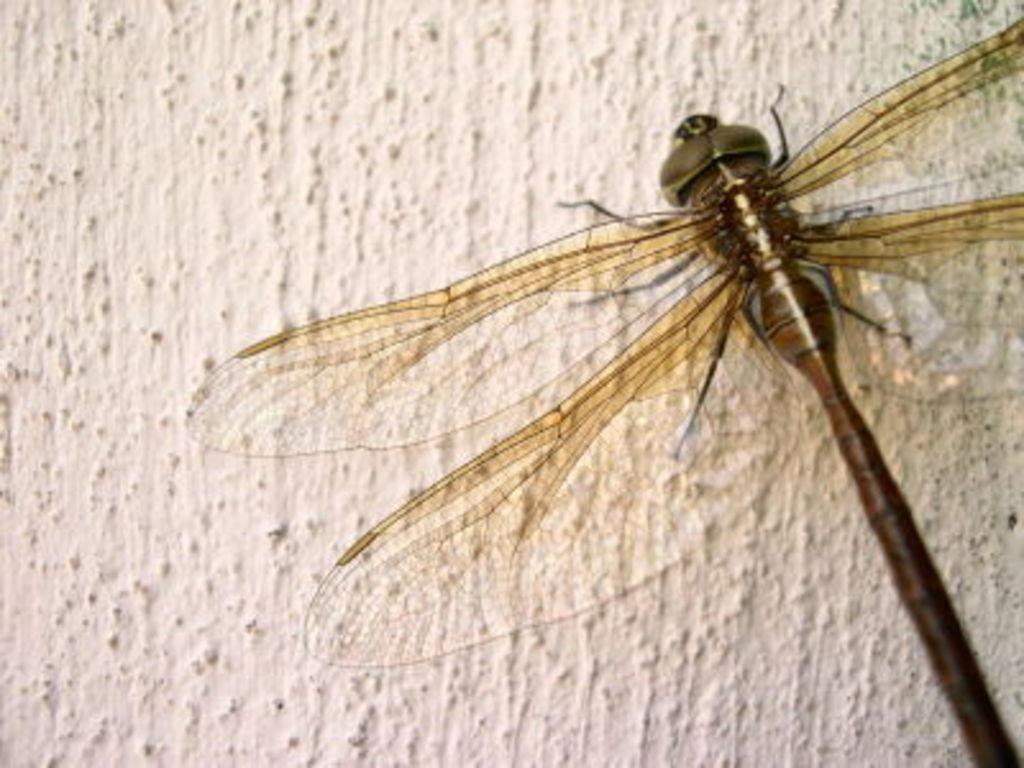What type of creature can be seen in the image? There is an insect in the image. Where is the insect located in the image? The insect is on a surface. What key is used to play the song that the insect is singing in the image? There is no song or key present in the image, as it only features an insect on a surface. What type of scissors can be seen cutting the grass in the image? There are no scissors or grass present in the image; it only features an insect on a surface. 